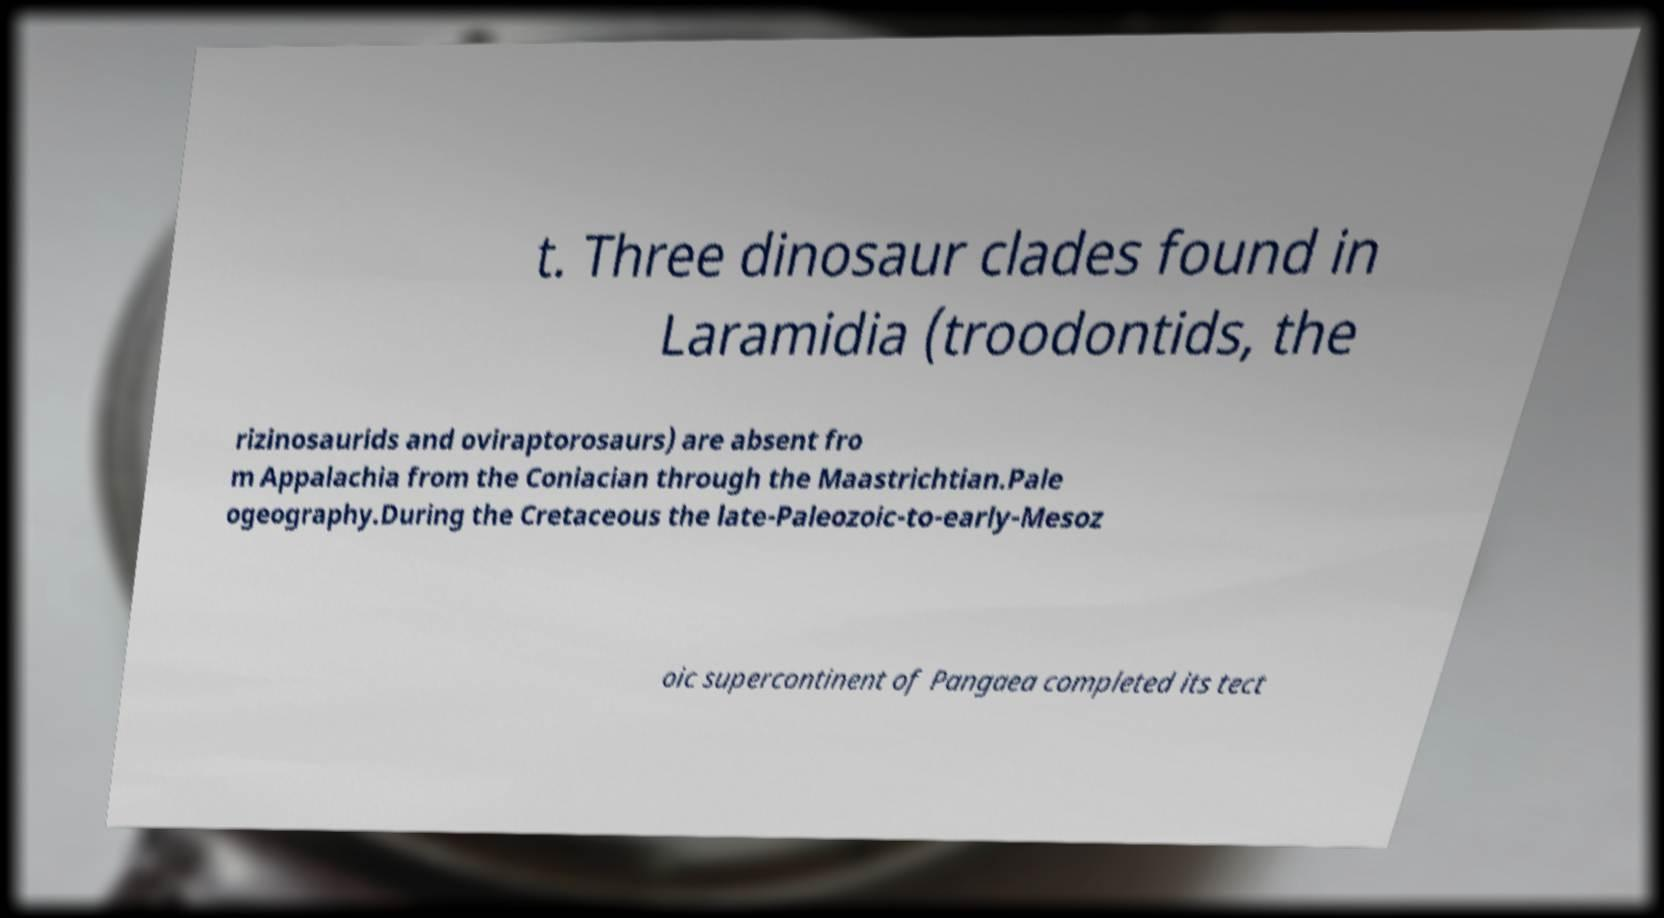Can you read and provide the text displayed in the image?This photo seems to have some interesting text. Can you extract and type it out for me? t. Three dinosaur clades found in Laramidia (troodontids, the rizinosaurids and oviraptorosaurs) are absent fro m Appalachia from the Coniacian through the Maastrichtian.Pale ogeography.During the Cretaceous the late-Paleozoic-to-early-Mesoz oic supercontinent of Pangaea completed its tect 